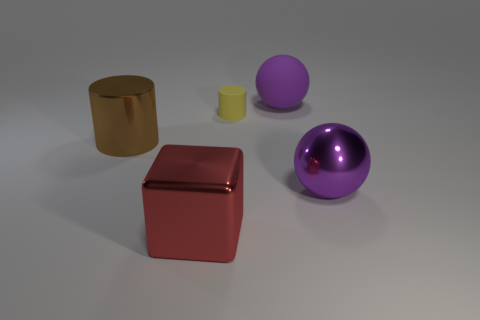There is a large purple thing that is the same material as the small yellow thing; what is its shape?
Your response must be concise. Sphere. How many large rubber things have the same color as the shiny ball?
Ensure brevity in your answer.  1. There is a sphere that is behind the brown cylinder; how big is it?
Provide a succinct answer. Large. What number of large purple objects are there?
Make the answer very short. 2. Does the tiny thing have the same color as the metallic block?
Ensure brevity in your answer.  No. There is a object that is both in front of the yellow rubber object and right of the large red thing; what color is it?
Your answer should be compact. Purple. Are there any matte things in front of the purple rubber sphere?
Give a very brief answer. Yes. What number of red metal blocks are on the right side of the purple rubber object to the left of the large purple metallic object?
Give a very brief answer. 0. What is the size of the yellow cylinder?
Provide a short and direct response. Small. Does the brown cylinder have the same material as the tiny object?
Provide a succinct answer. No. 